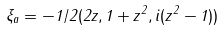<formula> <loc_0><loc_0><loc_500><loc_500>\xi _ { a } = - 1 / 2 ( 2 z , 1 + z ^ { 2 } , i ( z ^ { 2 } - 1 ) )</formula> 